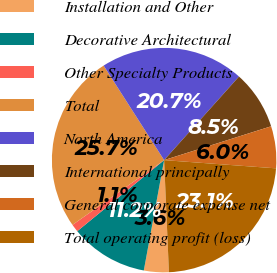Convert chart to OTSL. <chart><loc_0><loc_0><loc_500><loc_500><pie_chart><fcel>Installation and Other<fcel>Decorative Architectural<fcel>Other Specialty Products<fcel>Total<fcel>North America<fcel>International principally<fcel>General corporate expense net<fcel>Total operating profit (loss)<nl><fcel>3.58%<fcel>11.19%<fcel>1.12%<fcel>25.73%<fcel>20.69%<fcel>8.5%<fcel>6.04%<fcel>23.15%<nl></chart> 